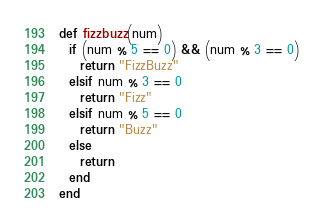<code> <loc_0><loc_0><loc_500><loc_500><_Ruby_>def fizzbuzz(num)
  if (num % 5 == 0) && (num % 3 == 0)
    return "FizzBuzz"
  elsif num % 3 == 0
    return "Fizz"
  elsif num % 5 == 0
    return "Buzz"
  else
    return
  end
end</code> 